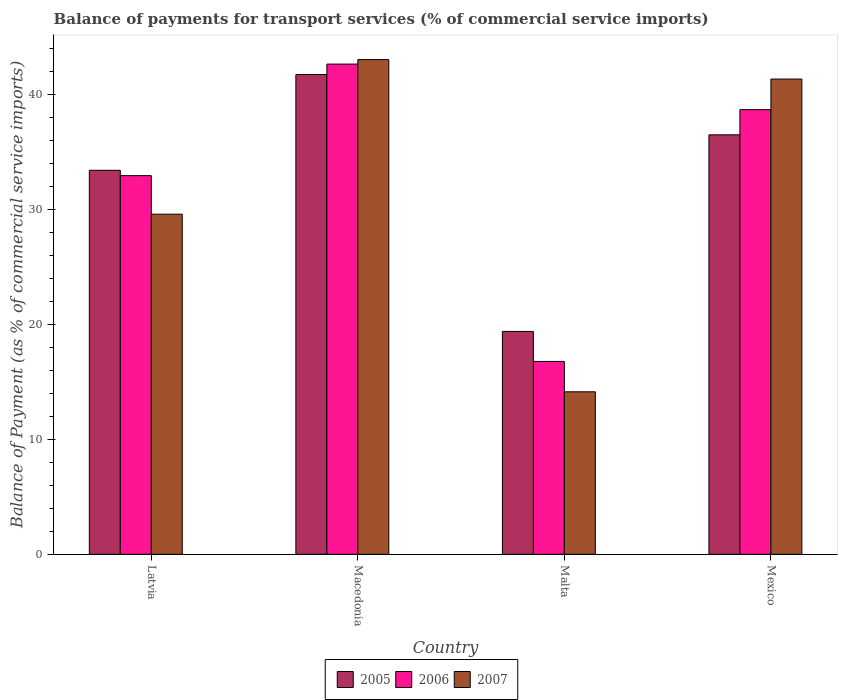How many groups of bars are there?
Your answer should be compact. 4. How many bars are there on the 2nd tick from the right?
Provide a short and direct response. 3. What is the label of the 3rd group of bars from the left?
Give a very brief answer. Malta. What is the balance of payments for transport services in 2005 in Malta?
Your response must be concise. 19.37. Across all countries, what is the maximum balance of payments for transport services in 2006?
Offer a terse response. 42.61. Across all countries, what is the minimum balance of payments for transport services in 2006?
Provide a succinct answer. 16.77. In which country was the balance of payments for transport services in 2007 maximum?
Keep it short and to the point. Macedonia. In which country was the balance of payments for transport services in 2006 minimum?
Keep it short and to the point. Malta. What is the total balance of payments for transport services in 2007 in the graph?
Make the answer very short. 128. What is the difference between the balance of payments for transport services in 2007 in Macedonia and that in Malta?
Your response must be concise. 28.88. What is the difference between the balance of payments for transport services in 2007 in Latvia and the balance of payments for transport services in 2006 in Malta?
Provide a succinct answer. 12.8. What is the average balance of payments for transport services in 2007 per country?
Offer a terse response. 32. What is the difference between the balance of payments for transport services of/in 2007 and balance of payments for transport services of/in 2006 in Latvia?
Your response must be concise. -3.35. In how many countries, is the balance of payments for transport services in 2007 greater than 14 %?
Your response must be concise. 4. What is the ratio of the balance of payments for transport services in 2007 in Latvia to that in Malta?
Your answer should be compact. 2.09. Is the difference between the balance of payments for transport services in 2007 in Macedonia and Malta greater than the difference between the balance of payments for transport services in 2006 in Macedonia and Malta?
Give a very brief answer. Yes. What is the difference between the highest and the second highest balance of payments for transport services in 2006?
Your response must be concise. -9.7. What is the difference between the highest and the lowest balance of payments for transport services in 2007?
Your answer should be very brief. 28.88. Is the sum of the balance of payments for transport services in 2005 in Macedonia and Malta greater than the maximum balance of payments for transport services in 2007 across all countries?
Make the answer very short. Yes. What does the 2nd bar from the right in Macedonia represents?
Give a very brief answer. 2006. Are the values on the major ticks of Y-axis written in scientific E-notation?
Offer a very short reply. No. Does the graph contain any zero values?
Your answer should be very brief. No. How many legend labels are there?
Your answer should be very brief. 3. How are the legend labels stacked?
Your response must be concise. Horizontal. What is the title of the graph?
Provide a short and direct response. Balance of payments for transport services (% of commercial service imports). What is the label or title of the Y-axis?
Give a very brief answer. Balance of Payment (as % of commercial service imports). What is the Balance of Payment (as % of commercial service imports) of 2005 in Latvia?
Your answer should be very brief. 33.38. What is the Balance of Payment (as % of commercial service imports) in 2006 in Latvia?
Provide a succinct answer. 32.92. What is the Balance of Payment (as % of commercial service imports) in 2007 in Latvia?
Provide a short and direct response. 29.56. What is the Balance of Payment (as % of commercial service imports) of 2005 in Macedonia?
Ensure brevity in your answer.  41.7. What is the Balance of Payment (as % of commercial service imports) of 2006 in Macedonia?
Offer a very short reply. 42.61. What is the Balance of Payment (as % of commercial service imports) in 2007 in Macedonia?
Your answer should be compact. 43. What is the Balance of Payment (as % of commercial service imports) in 2005 in Malta?
Your answer should be very brief. 19.37. What is the Balance of Payment (as % of commercial service imports) of 2006 in Malta?
Ensure brevity in your answer.  16.77. What is the Balance of Payment (as % of commercial service imports) of 2007 in Malta?
Give a very brief answer. 14.12. What is the Balance of Payment (as % of commercial service imports) in 2005 in Mexico?
Your answer should be compact. 36.46. What is the Balance of Payment (as % of commercial service imports) in 2006 in Mexico?
Your response must be concise. 38.65. What is the Balance of Payment (as % of commercial service imports) of 2007 in Mexico?
Provide a short and direct response. 41.31. Across all countries, what is the maximum Balance of Payment (as % of commercial service imports) in 2005?
Your answer should be very brief. 41.7. Across all countries, what is the maximum Balance of Payment (as % of commercial service imports) in 2006?
Give a very brief answer. 42.61. Across all countries, what is the maximum Balance of Payment (as % of commercial service imports) of 2007?
Make the answer very short. 43. Across all countries, what is the minimum Balance of Payment (as % of commercial service imports) of 2005?
Provide a succinct answer. 19.37. Across all countries, what is the minimum Balance of Payment (as % of commercial service imports) in 2006?
Your response must be concise. 16.77. Across all countries, what is the minimum Balance of Payment (as % of commercial service imports) of 2007?
Ensure brevity in your answer.  14.12. What is the total Balance of Payment (as % of commercial service imports) of 2005 in the graph?
Provide a succinct answer. 130.92. What is the total Balance of Payment (as % of commercial service imports) of 2006 in the graph?
Provide a succinct answer. 130.95. What is the total Balance of Payment (as % of commercial service imports) of 2007 in the graph?
Your answer should be very brief. 128. What is the difference between the Balance of Payment (as % of commercial service imports) in 2005 in Latvia and that in Macedonia?
Your answer should be compact. -8.32. What is the difference between the Balance of Payment (as % of commercial service imports) of 2006 in Latvia and that in Macedonia?
Your answer should be compact. -9.7. What is the difference between the Balance of Payment (as % of commercial service imports) of 2007 in Latvia and that in Macedonia?
Ensure brevity in your answer.  -13.44. What is the difference between the Balance of Payment (as % of commercial service imports) in 2005 in Latvia and that in Malta?
Your answer should be very brief. 14.01. What is the difference between the Balance of Payment (as % of commercial service imports) of 2006 in Latvia and that in Malta?
Give a very brief answer. 16.15. What is the difference between the Balance of Payment (as % of commercial service imports) of 2007 in Latvia and that in Malta?
Offer a very short reply. 15.44. What is the difference between the Balance of Payment (as % of commercial service imports) in 2005 in Latvia and that in Mexico?
Offer a very short reply. -3.08. What is the difference between the Balance of Payment (as % of commercial service imports) of 2006 in Latvia and that in Mexico?
Your response must be concise. -5.73. What is the difference between the Balance of Payment (as % of commercial service imports) in 2007 in Latvia and that in Mexico?
Provide a short and direct response. -11.75. What is the difference between the Balance of Payment (as % of commercial service imports) of 2005 in Macedonia and that in Malta?
Provide a succinct answer. 22.33. What is the difference between the Balance of Payment (as % of commercial service imports) of 2006 in Macedonia and that in Malta?
Your answer should be compact. 25.85. What is the difference between the Balance of Payment (as % of commercial service imports) in 2007 in Macedonia and that in Malta?
Ensure brevity in your answer.  28.88. What is the difference between the Balance of Payment (as % of commercial service imports) of 2005 in Macedonia and that in Mexico?
Keep it short and to the point. 5.24. What is the difference between the Balance of Payment (as % of commercial service imports) in 2006 in Macedonia and that in Mexico?
Provide a succinct answer. 3.96. What is the difference between the Balance of Payment (as % of commercial service imports) in 2007 in Macedonia and that in Mexico?
Keep it short and to the point. 1.69. What is the difference between the Balance of Payment (as % of commercial service imports) in 2005 in Malta and that in Mexico?
Your answer should be compact. -17.09. What is the difference between the Balance of Payment (as % of commercial service imports) of 2006 in Malta and that in Mexico?
Your answer should be very brief. -21.89. What is the difference between the Balance of Payment (as % of commercial service imports) of 2007 in Malta and that in Mexico?
Give a very brief answer. -27.19. What is the difference between the Balance of Payment (as % of commercial service imports) in 2005 in Latvia and the Balance of Payment (as % of commercial service imports) in 2006 in Macedonia?
Keep it short and to the point. -9.23. What is the difference between the Balance of Payment (as % of commercial service imports) of 2005 in Latvia and the Balance of Payment (as % of commercial service imports) of 2007 in Macedonia?
Provide a short and direct response. -9.62. What is the difference between the Balance of Payment (as % of commercial service imports) of 2006 in Latvia and the Balance of Payment (as % of commercial service imports) of 2007 in Macedonia?
Make the answer very short. -10.09. What is the difference between the Balance of Payment (as % of commercial service imports) in 2005 in Latvia and the Balance of Payment (as % of commercial service imports) in 2006 in Malta?
Your answer should be compact. 16.62. What is the difference between the Balance of Payment (as % of commercial service imports) of 2005 in Latvia and the Balance of Payment (as % of commercial service imports) of 2007 in Malta?
Ensure brevity in your answer.  19.26. What is the difference between the Balance of Payment (as % of commercial service imports) in 2006 in Latvia and the Balance of Payment (as % of commercial service imports) in 2007 in Malta?
Offer a terse response. 18.79. What is the difference between the Balance of Payment (as % of commercial service imports) of 2005 in Latvia and the Balance of Payment (as % of commercial service imports) of 2006 in Mexico?
Your response must be concise. -5.27. What is the difference between the Balance of Payment (as % of commercial service imports) in 2005 in Latvia and the Balance of Payment (as % of commercial service imports) in 2007 in Mexico?
Your response must be concise. -7.93. What is the difference between the Balance of Payment (as % of commercial service imports) of 2006 in Latvia and the Balance of Payment (as % of commercial service imports) of 2007 in Mexico?
Ensure brevity in your answer.  -8.39. What is the difference between the Balance of Payment (as % of commercial service imports) in 2005 in Macedonia and the Balance of Payment (as % of commercial service imports) in 2006 in Malta?
Your answer should be compact. 24.94. What is the difference between the Balance of Payment (as % of commercial service imports) of 2005 in Macedonia and the Balance of Payment (as % of commercial service imports) of 2007 in Malta?
Provide a short and direct response. 27.58. What is the difference between the Balance of Payment (as % of commercial service imports) of 2006 in Macedonia and the Balance of Payment (as % of commercial service imports) of 2007 in Malta?
Your answer should be compact. 28.49. What is the difference between the Balance of Payment (as % of commercial service imports) of 2005 in Macedonia and the Balance of Payment (as % of commercial service imports) of 2006 in Mexico?
Provide a short and direct response. 3.05. What is the difference between the Balance of Payment (as % of commercial service imports) in 2005 in Macedonia and the Balance of Payment (as % of commercial service imports) in 2007 in Mexico?
Give a very brief answer. 0.39. What is the difference between the Balance of Payment (as % of commercial service imports) of 2006 in Macedonia and the Balance of Payment (as % of commercial service imports) of 2007 in Mexico?
Your answer should be compact. 1.3. What is the difference between the Balance of Payment (as % of commercial service imports) of 2005 in Malta and the Balance of Payment (as % of commercial service imports) of 2006 in Mexico?
Make the answer very short. -19.28. What is the difference between the Balance of Payment (as % of commercial service imports) in 2005 in Malta and the Balance of Payment (as % of commercial service imports) in 2007 in Mexico?
Provide a short and direct response. -21.94. What is the difference between the Balance of Payment (as % of commercial service imports) in 2006 in Malta and the Balance of Payment (as % of commercial service imports) in 2007 in Mexico?
Your answer should be very brief. -24.55. What is the average Balance of Payment (as % of commercial service imports) in 2005 per country?
Your answer should be compact. 32.73. What is the average Balance of Payment (as % of commercial service imports) of 2006 per country?
Provide a succinct answer. 32.74. What is the average Balance of Payment (as % of commercial service imports) of 2007 per country?
Give a very brief answer. 32. What is the difference between the Balance of Payment (as % of commercial service imports) of 2005 and Balance of Payment (as % of commercial service imports) of 2006 in Latvia?
Your answer should be very brief. 0.46. What is the difference between the Balance of Payment (as % of commercial service imports) in 2005 and Balance of Payment (as % of commercial service imports) in 2007 in Latvia?
Make the answer very short. 3.82. What is the difference between the Balance of Payment (as % of commercial service imports) of 2006 and Balance of Payment (as % of commercial service imports) of 2007 in Latvia?
Offer a very short reply. 3.35. What is the difference between the Balance of Payment (as % of commercial service imports) in 2005 and Balance of Payment (as % of commercial service imports) in 2006 in Macedonia?
Make the answer very short. -0.91. What is the difference between the Balance of Payment (as % of commercial service imports) of 2005 and Balance of Payment (as % of commercial service imports) of 2007 in Macedonia?
Your answer should be compact. -1.3. What is the difference between the Balance of Payment (as % of commercial service imports) of 2006 and Balance of Payment (as % of commercial service imports) of 2007 in Macedonia?
Keep it short and to the point. -0.39. What is the difference between the Balance of Payment (as % of commercial service imports) of 2005 and Balance of Payment (as % of commercial service imports) of 2006 in Malta?
Offer a very short reply. 2.61. What is the difference between the Balance of Payment (as % of commercial service imports) of 2005 and Balance of Payment (as % of commercial service imports) of 2007 in Malta?
Your answer should be very brief. 5.25. What is the difference between the Balance of Payment (as % of commercial service imports) in 2006 and Balance of Payment (as % of commercial service imports) in 2007 in Malta?
Offer a terse response. 2.64. What is the difference between the Balance of Payment (as % of commercial service imports) in 2005 and Balance of Payment (as % of commercial service imports) in 2006 in Mexico?
Ensure brevity in your answer.  -2.19. What is the difference between the Balance of Payment (as % of commercial service imports) in 2005 and Balance of Payment (as % of commercial service imports) in 2007 in Mexico?
Offer a terse response. -4.85. What is the difference between the Balance of Payment (as % of commercial service imports) in 2006 and Balance of Payment (as % of commercial service imports) in 2007 in Mexico?
Ensure brevity in your answer.  -2.66. What is the ratio of the Balance of Payment (as % of commercial service imports) in 2005 in Latvia to that in Macedonia?
Ensure brevity in your answer.  0.8. What is the ratio of the Balance of Payment (as % of commercial service imports) of 2006 in Latvia to that in Macedonia?
Provide a succinct answer. 0.77. What is the ratio of the Balance of Payment (as % of commercial service imports) in 2007 in Latvia to that in Macedonia?
Your response must be concise. 0.69. What is the ratio of the Balance of Payment (as % of commercial service imports) of 2005 in Latvia to that in Malta?
Provide a succinct answer. 1.72. What is the ratio of the Balance of Payment (as % of commercial service imports) of 2006 in Latvia to that in Malta?
Give a very brief answer. 1.96. What is the ratio of the Balance of Payment (as % of commercial service imports) of 2007 in Latvia to that in Malta?
Offer a very short reply. 2.09. What is the ratio of the Balance of Payment (as % of commercial service imports) in 2005 in Latvia to that in Mexico?
Your answer should be very brief. 0.92. What is the ratio of the Balance of Payment (as % of commercial service imports) of 2006 in Latvia to that in Mexico?
Provide a succinct answer. 0.85. What is the ratio of the Balance of Payment (as % of commercial service imports) of 2007 in Latvia to that in Mexico?
Offer a terse response. 0.72. What is the ratio of the Balance of Payment (as % of commercial service imports) of 2005 in Macedonia to that in Malta?
Ensure brevity in your answer.  2.15. What is the ratio of the Balance of Payment (as % of commercial service imports) of 2006 in Macedonia to that in Malta?
Make the answer very short. 2.54. What is the ratio of the Balance of Payment (as % of commercial service imports) of 2007 in Macedonia to that in Malta?
Your response must be concise. 3.04. What is the ratio of the Balance of Payment (as % of commercial service imports) of 2005 in Macedonia to that in Mexico?
Give a very brief answer. 1.14. What is the ratio of the Balance of Payment (as % of commercial service imports) of 2006 in Macedonia to that in Mexico?
Offer a terse response. 1.1. What is the ratio of the Balance of Payment (as % of commercial service imports) of 2007 in Macedonia to that in Mexico?
Provide a short and direct response. 1.04. What is the ratio of the Balance of Payment (as % of commercial service imports) in 2005 in Malta to that in Mexico?
Give a very brief answer. 0.53. What is the ratio of the Balance of Payment (as % of commercial service imports) of 2006 in Malta to that in Mexico?
Give a very brief answer. 0.43. What is the ratio of the Balance of Payment (as % of commercial service imports) in 2007 in Malta to that in Mexico?
Offer a terse response. 0.34. What is the difference between the highest and the second highest Balance of Payment (as % of commercial service imports) of 2005?
Offer a terse response. 5.24. What is the difference between the highest and the second highest Balance of Payment (as % of commercial service imports) in 2006?
Your answer should be compact. 3.96. What is the difference between the highest and the second highest Balance of Payment (as % of commercial service imports) of 2007?
Make the answer very short. 1.69. What is the difference between the highest and the lowest Balance of Payment (as % of commercial service imports) in 2005?
Keep it short and to the point. 22.33. What is the difference between the highest and the lowest Balance of Payment (as % of commercial service imports) of 2006?
Make the answer very short. 25.85. What is the difference between the highest and the lowest Balance of Payment (as % of commercial service imports) in 2007?
Keep it short and to the point. 28.88. 